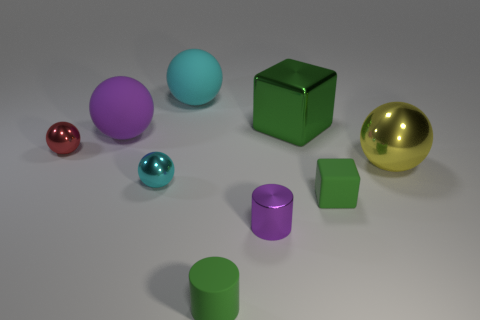The green thing that is the same material as the big yellow sphere is what shape?
Your answer should be compact. Cube. Is there anything else of the same color as the tiny rubber cylinder?
Provide a short and direct response. Yes. What material is the small cylinder that is to the right of the cylinder in front of the tiny metallic cylinder made of?
Your answer should be compact. Metal. Is there a small yellow metal thing of the same shape as the small red metallic object?
Offer a terse response. No. How many other objects are there of the same shape as the large purple thing?
Provide a succinct answer. 4. What is the shape of the small shiny object that is left of the large cyan thing and right of the red ball?
Make the answer very short. Sphere. What size is the shiny thing that is on the right side of the matte block?
Your answer should be very brief. Large. Do the green metallic cube and the cyan metallic object have the same size?
Your answer should be compact. No. Is the number of red spheres in front of the tiny cyan thing less than the number of green rubber cubes that are behind the small red thing?
Your response must be concise. No. How big is the thing that is both in front of the cyan shiny thing and to the right of the shiny block?
Offer a very short reply. Small. 